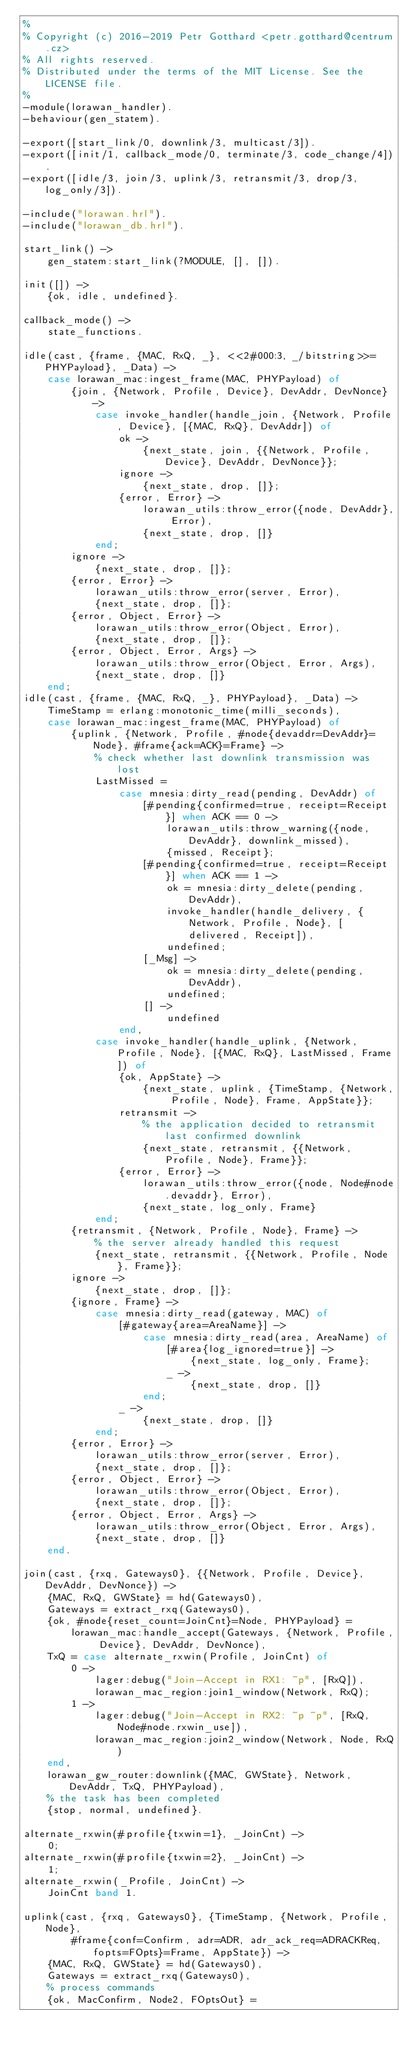Convert code to text. <code><loc_0><loc_0><loc_500><loc_500><_Erlang_>%
% Copyright (c) 2016-2019 Petr Gotthard <petr.gotthard@centrum.cz>
% All rights reserved.
% Distributed under the terms of the MIT License. See the LICENSE file.
%
-module(lorawan_handler).
-behaviour(gen_statem).

-export([start_link/0, downlink/3, multicast/3]).
-export([init/1, callback_mode/0, terminate/3, code_change/4]).
-export([idle/3, join/3, uplink/3, retransmit/3, drop/3, log_only/3]).

-include("lorawan.hrl").
-include("lorawan_db.hrl").

start_link() ->
    gen_statem:start_link(?MODULE, [], []).

init([]) ->
    {ok, idle, undefined}.

callback_mode() ->
    state_functions.

idle(cast, {frame, {MAC, RxQ, _}, <<2#000:3, _/bitstring>>=PHYPayload}, _Data) ->
    case lorawan_mac:ingest_frame(MAC, PHYPayload) of
        {join, {Network, Profile, Device}, DevAddr, DevNonce} ->
            case invoke_handler(handle_join, {Network, Profile, Device}, [{MAC, RxQ}, DevAddr]) of
                ok ->
                    {next_state, join, {{Network, Profile, Device}, DevAddr, DevNonce}};
                ignore ->
                    {next_state, drop, []};
                {error, Error} ->
                    lorawan_utils:throw_error({node, DevAddr}, Error),
                    {next_state, drop, []}
            end;
        ignore ->
            {next_state, drop, []};
        {error, Error} ->
            lorawan_utils:throw_error(server, Error),
            {next_state, drop, []};
        {error, Object, Error} ->
            lorawan_utils:throw_error(Object, Error),
            {next_state, drop, []};
        {error, Object, Error, Args} ->
            lorawan_utils:throw_error(Object, Error, Args),
            {next_state, drop, []}
    end;
idle(cast, {frame, {MAC, RxQ, _}, PHYPayload}, _Data) ->
    TimeStamp = erlang:monotonic_time(milli_seconds),
    case lorawan_mac:ingest_frame(MAC, PHYPayload) of
        {uplink, {Network, Profile, #node{devaddr=DevAddr}=Node}, #frame{ack=ACK}=Frame} ->
            % check whether last downlink transmission was lost
            LastMissed =
                case mnesia:dirty_read(pending, DevAddr) of
                    [#pending{confirmed=true, receipt=Receipt}] when ACK == 0 ->
                        lorawan_utils:throw_warning({node, DevAddr}, downlink_missed),
                        {missed, Receipt};
                    [#pending{confirmed=true, receipt=Receipt}] when ACK == 1 ->
                        ok = mnesia:dirty_delete(pending, DevAddr),
                        invoke_handler(handle_delivery, {Network, Profile, Node}, [delivered, Receipt]),
                        undefined;
                    [_Msg] ->
                        ok = mnesia:dirty_delete(pending, DevAddr),
                        undefined;
                    [] ->
                        undefined
                end,
            case invoke_handler(handle_uplink, {Network, Profile, Node}, [{MAC, RxQ}, LastMissed, Frame]) of
                {ok, AppState} ->
                    {next_state, uplink, {TimeStamp, {Network, Profile, Node}, Frame, AppState}};
                retransmit ->
                    % the application decided to retransmit last confirmed downlink
                    {next_state, retransmit, {{Network, Profile, Node}, Frame}};
                {error, Error} ->
                    lorawan_utils:throw_error({node, Node#node.devaddr}, Error),
                    {next_state, log_only, Frame}
            end;
        {retransmit, {Network, Profile, Node}, Frame} ->
            % the server already handled this request
            {next_state, retransmit, {{Network, Profile, Node}, Frame}};
        ignore ->
            {next_state, drop, []};
        {ignore, Frame} ->
            case mnesia:dirty_read(gateway, MAC) of
                [#gateway{area=AreaName}] ->
                    case mnesia:dirty_read(area, AreaName) of
                        [#area{log_ignored=true}] ->
                            {next_state, log_only, Frame};
                        _ ->
                            {next_state, drop, []}
                    end;
                _ ->
                    {next_state, drop, []}
            end;
        {error, Error} ->
            lorawan_utils:throw_error(server, Error),
            {next_state, drop, []};
        {error, Object, Error} ->
            lorawan_utils:throw_error(Object, Error),
            {next_state, drop, []};
        {error, Object, Error, Args} ->
            lorawan_utils:throw_error(Object, Error, Args),
            {next_state, drop, []}
    end.

join(cast, {rxq, Gateways0}, {{Network, Profile, Device}, DevAddr, DevNonce}) ->
    {MAC, RxQ, GWState} = hd(Gateways0),
    Gateways = extract_rxq(Gateways0),
    {ok, #node{reset_count=JoinCnt}=Node, PHYPayload} =
        lorawan_mac:handle_accept(Gateways, {Network, Profile, Device}, DevAddr, DevNonce),
    TxQ = case alternate_rxwin(Profile, JoinCnt) of
        0 ->
            lager:debug("Join-Accept in RX1: ~p", [RxQ]),
            lorawan_mac_region:join1_window(Network, RxQ);
        1 ->
            lager:debug("Join-Accept in RX2: ~p ~p", [RxQ, Node#node.rxwin_use]),
            lorawan_mac_region:join2_window(Network, Node, RxQ)
    end,
    lorawan_gw_router:downlink({MAC, GWState}, Network, DevAddr, TxQ, PHYPayload),
    % the task has been completed
    {stop, normal, undefined}.

alternate_rxwin(#profile{txwin=1}, _JoinCnt) ->
    0;
alternate_rxwin(#profile{txwin=2}, _JoinCnt) ->
    1;
alternate_rxwin(_Profile, JoinCnt) ->
    JoinCnt band 1.

uplink(cast, {rxq, Gateways0}, {TimeStamp, {Network, Profile, Node},
        #frame{conf=Confirm, adr=ADR, adr_ack_req=ADRACKReq, fopts=FOpts}=Frame, AppState}) ->
    {MAC, RxQ, GWState} = hd(Gateways0),
    Gateways = extract_rxq(Gateways0),
    % process commands
    {ok, MacConfirm, Node2, FOptsOut} =</code> 